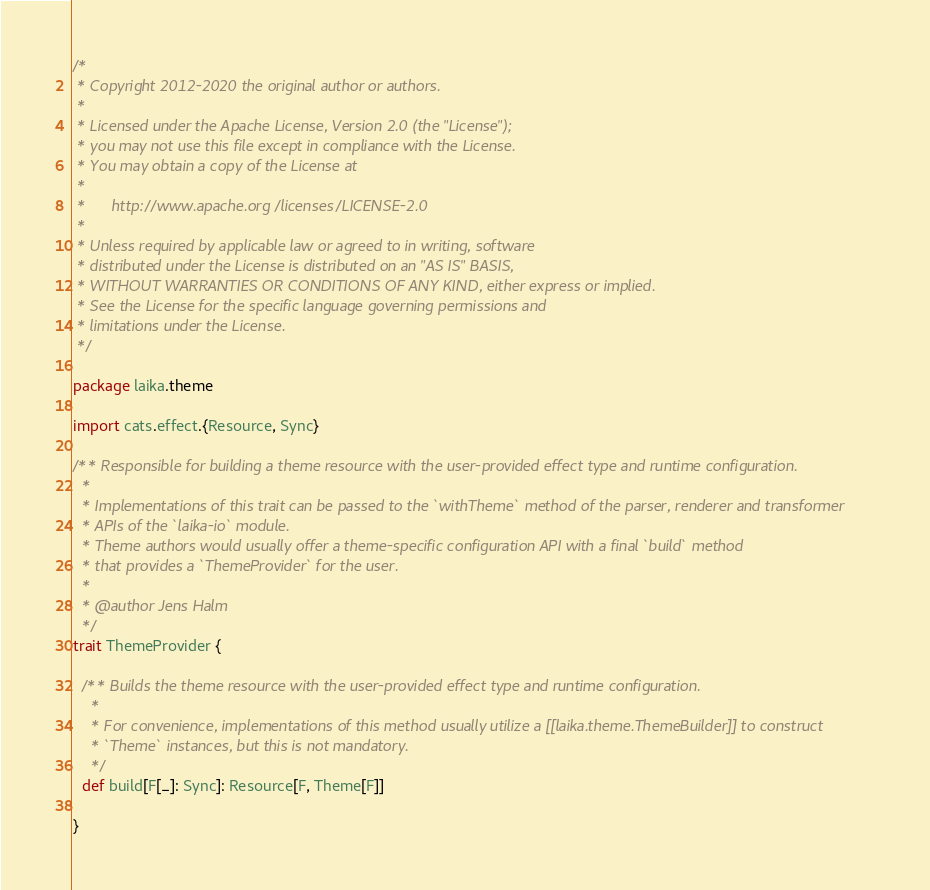<code> <loc_0><loc_0><loc_500><loc_500><_Scala_>/*
 * Copyright 2012-2020 the original author or authors.
 *
 * Licensed under the Apache License, Version 2.0 (the "License");
 * you may not use this file except in compliance with the License.
 * You may obtain a copy of the License at
 *
 *      http://www.apache.org/licenses/LICENSE-2.0
 *
 * Unless required by applicable law or agreed to in writing, software
 * distributed under the License is distributed on an "AS IS" BASIS,
 * WITHOUT WARRANTIES OR CONDITIONS OF ANY KIND, either express or implied.
 * See the License for the specific language governing permissions and
 * limitations under the License.
 */

package laika.theme

import cats.effect.{Resource, Sync}

/** Responsible for building a theme resource with the user-provided effect type and runtime configuration.
  * 
  * Implementations of this trait can be passed to the `withTheme` method of the parser, renderer and transformer
  * APIs of the `laika-io` module.
  * Theme authors would usually offer a theme-specific configuration API with a final `build` method
  * that provides a `ThemeProvider` for the user.
  * 
  * @author Jens Halm
  */
trait ThemeProvider {

  /** Builds the theme resource with the user-provided effect type and runtime configuration.
    * 
    * For convenience, implementations of this method usually utilize a [[laika.theme.ThemeBuilder]] to construct
    * `Theme` instances, but this is not mandatory.
    */
  def build[F[_]: Sync]: Resource[F, Theme[F]]
  
}
</code> 